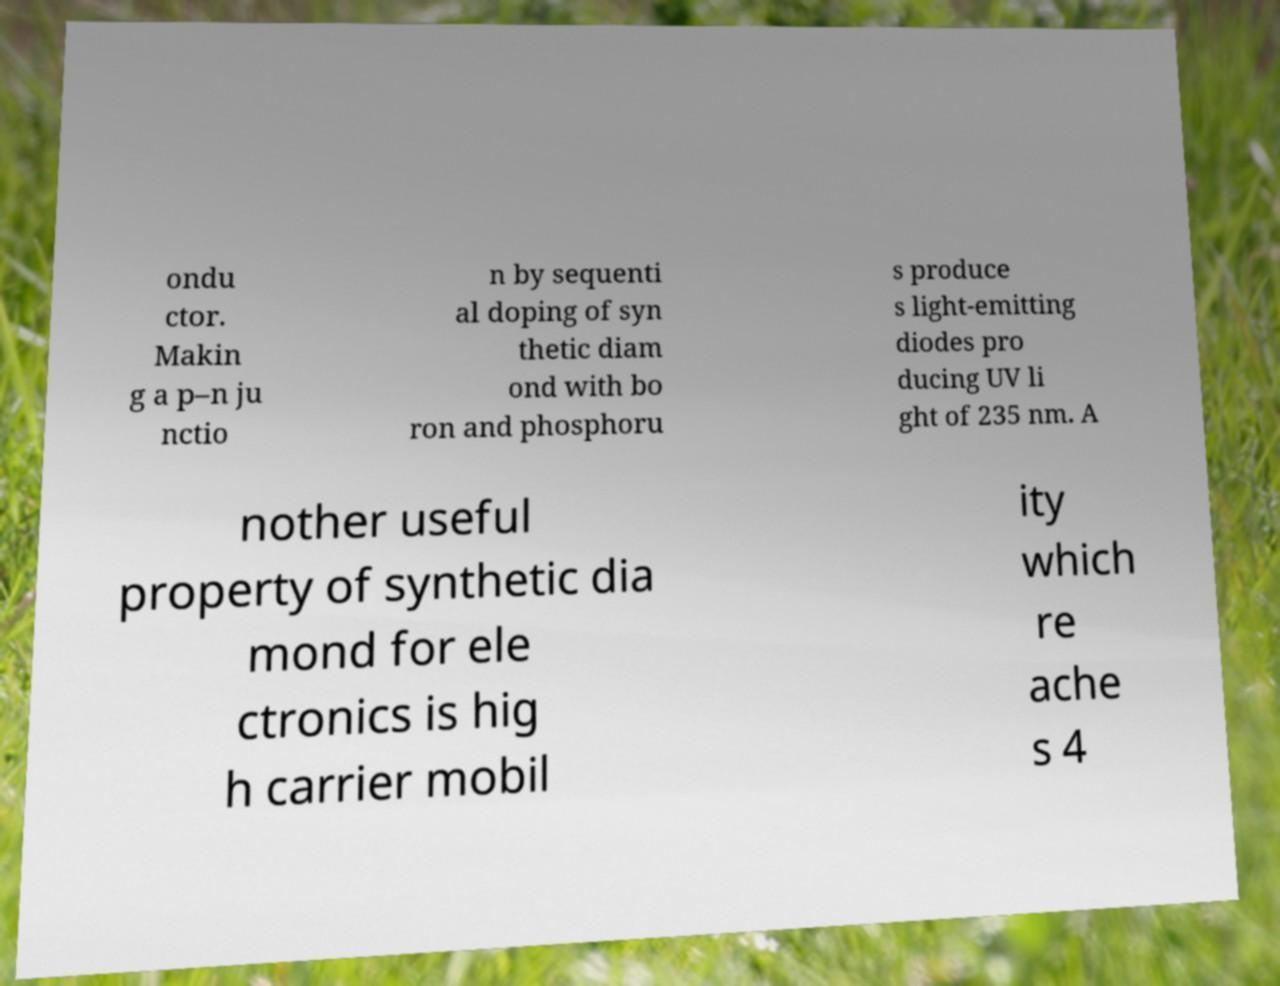Can you accurately transcribe the text from the provided image for me? ondu ctor. Makin g a p–n ju nctio n by sequenti al doping of syn thetic diam ond with bo ron and phosphoru s produce s light-emitting diodes pro ducing UV li ght of 235 nm. A nother useful property of synthetic dia mond for ele ctronics is hig h carrier mobil ity which re ache s 4 